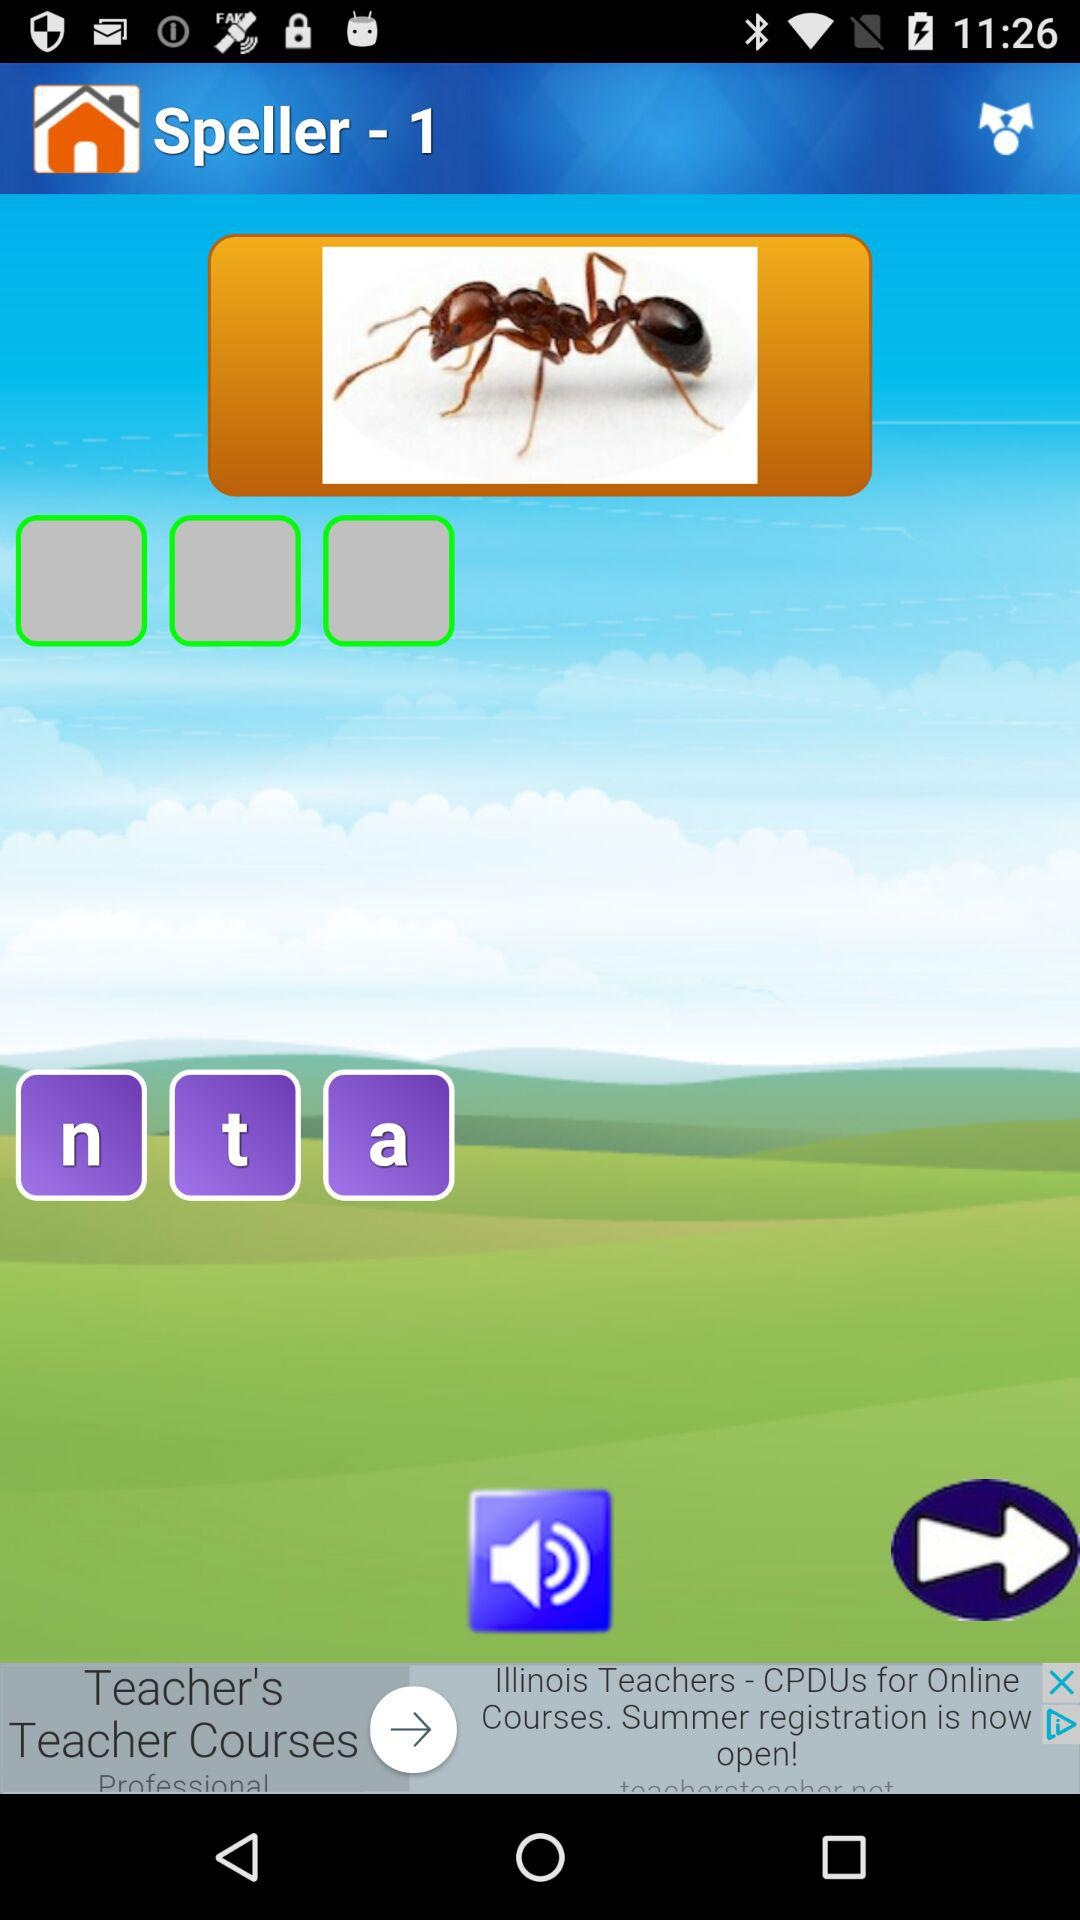What is the application name? The application name is "Speller - 1". 